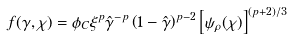Convert formula to latex. <formula><loc_0><loc_0><loc_500><loc_500>f ( \gamma , \chi ) = \phi _ { C } \xi ^ { p } { \hat { \gamma } } ^ { - p } \left ( 1 - \hat { \gamma } \right ) ^ { p - 2 } \left [ \psi _ { \rho } ( \chi ) \right ] ^ { ( p + 2 ) / 3 }</formula> 